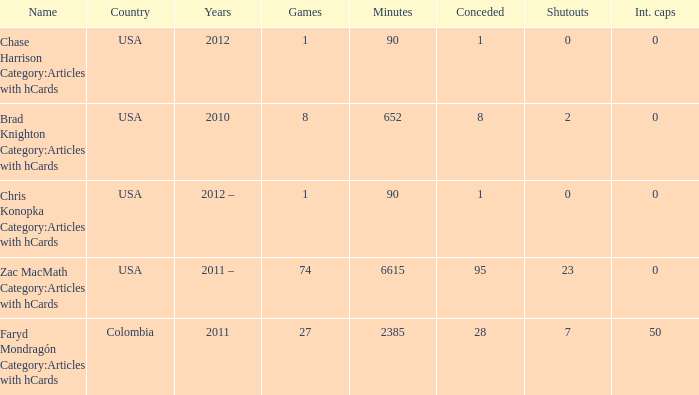When  chris konopka category:articles with hcards is the name what is the year? 2012 –. 